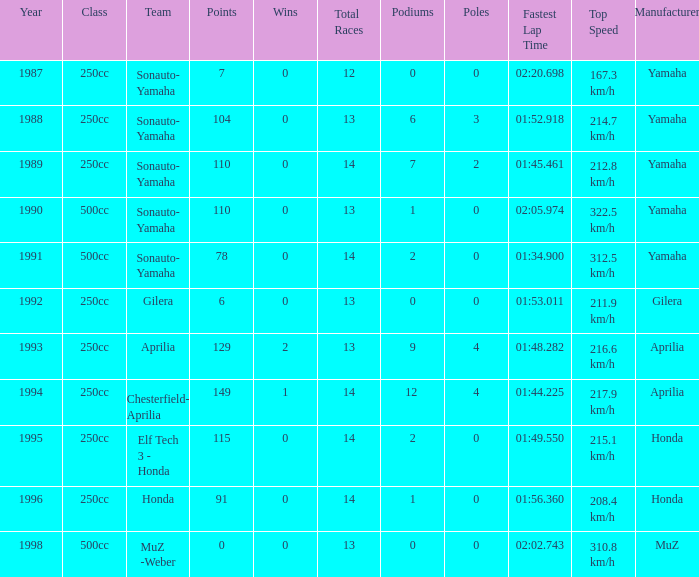What is the highest number of points the team with 0 wins had before 1992? 110.0. 